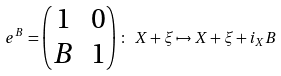Convert formula to latex. <formula><loc_0><loc_0><loc_500><loc_500>e ^ { B } = \left ( \begin{matrix} 1 & 0 \\ B & 1 \end{matrix} \right ) \colon \ X + \xi \mapsto X + \xi + i _ { X } B</formula> 